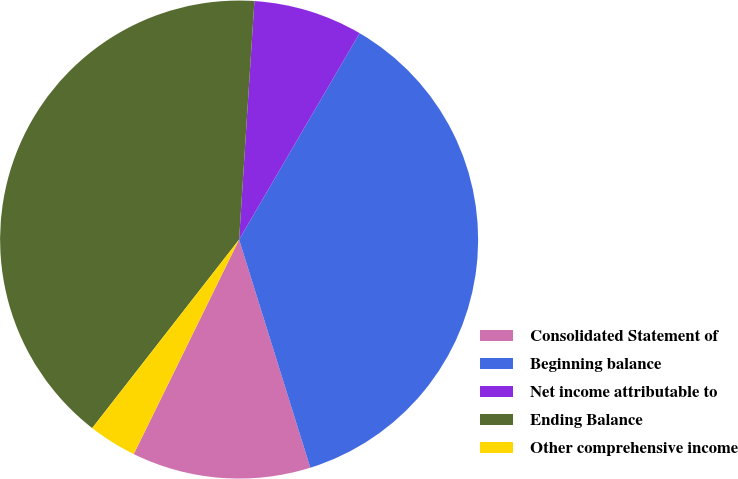<chart> <loc_0><loc_0><loc_500><loc_500><pie_chart><fcel>Consolidated Statement of<fcel>Beginning balance<fcel>Net income attributable to<fcel>Ending Balance<fcel>Other comprehensive income<nl><fcel>12.08%<fcel>36.77%<fcel>7.39%<fcel>40.48%<fcel>3.27%<nl></chart> 